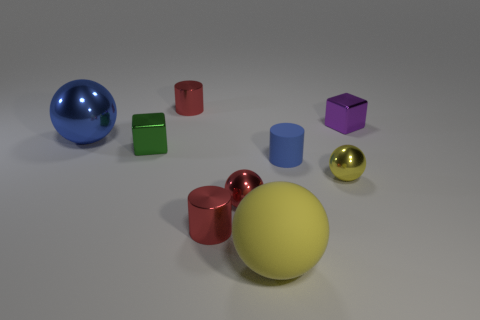How many yellow balls must be subtracted to get 1 yellow balls? 1 Subtract 1 balls. How many balls are left? 3 Subtract all balls. How many objects are left? 5 Add 1 red spheres. How many red spheres exist? 2 Subtract 0 gray spheres. How many objects are left? 9 Subtract all big blue objects. Subtract all shiny balls. How many objects are left? 5 Add 3 big yellow things. How many big yellow things are left? 4 